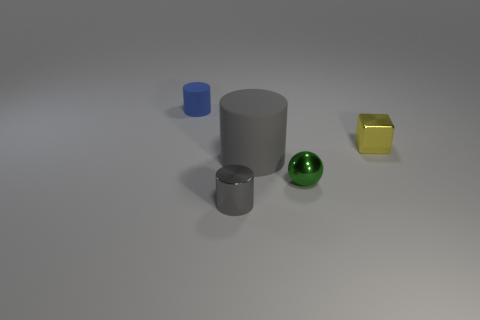Subtract all matte cylinders. How many cylinders are left? 1 Subtract all red balls. How many gray cylinders are left? 2 Subtract all blue cylinders. How many cylinders are left? 2 Add 5 blue things. How many objects exist? 10 Subtract 1 cylinders. How many cylinders are left? 2 Subtract all blocks. How many objects are left? 4 Subtract all brown blocks. Subtract all purple cylinders. How many blocks are left? 1 Subtract all green things. Subtract all gray cylinders. How many objects are left? 2 Add 5 blue rubber cylinders. How many blue rubber cylinders are left? 6 Add 4 tiny rubber things. How many tiny rubber things exist? 5 